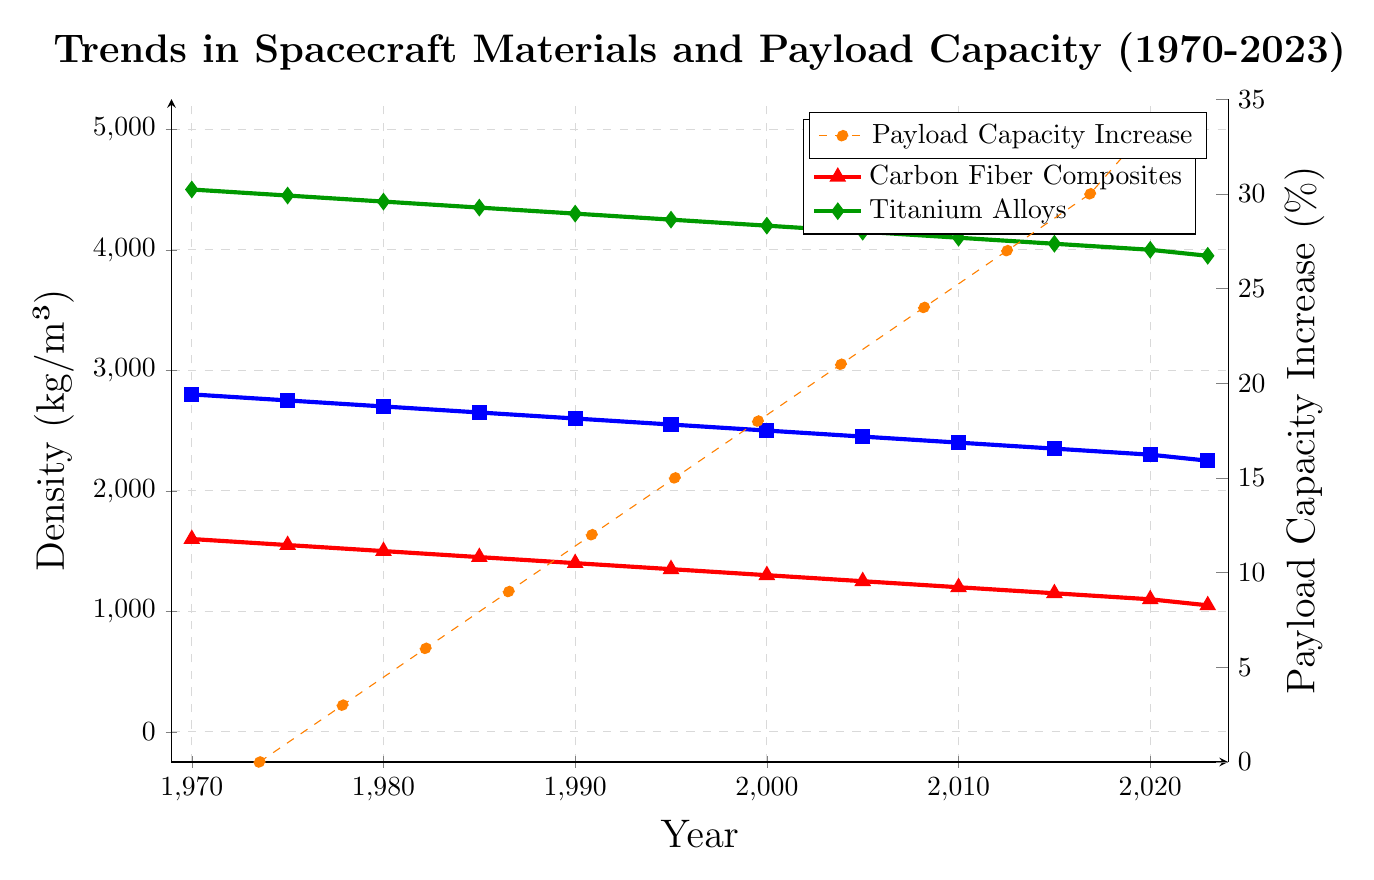Which material saw the greatest reduction in density from 1970 to 2023? To determine the material with the greatest reduction in density, calculate the difference in density for each material between 1970 and 2023. For Aluminum Alloy: 2800 - 2250 = 550 kg/m³. For Carbon Fiber Composites: 1600 - 1050 = 550 kg/m³. For Titanium Alloys: 4500 - 3950 = 550 kg/m³. All materials saw the same reduction in density.
Answer: All materials Between which two consecutive time points did the Payload Capacity Increase by the greatest percentage? To find this, compute the change in Payload Capacity Increase between each pair of consecutive data points: (1970-1975)=(3-0)=3, (1975-1980)=(6-3)=3, (1980-1985)=(9-6)=3, (1985-1990)=(12-9)=3, (1990-1995)=(15-12)=3, (1995-2000)=(18-15)=3, (2000-2005)=(21-18)=3, (2005-2010)=(24-21)=3, (2010-2015)=(27-24)=3, (2015-2020)=(30-27)=3, (2020-2023)=(33-30)=3. Each increment is the same; thus, the greatest increase is the same at each interval.
Answer: All intervals (3%) What is the average density of Titanium Alloys from 1970 to 2023? To find the average density of Titanium Alloys over this period, sum up the densities and divide by the number of years: (4500 + 4450 + 4400 + 4350 + 4300 + 4250 + 4200 + 4150 + 4100 + 4050 + 4000 + 3950) / 12 = 50900 / 12.
Answer: 4241.67 kg/m³ How does the density of Carbon Fiber Composites in 2023 compare to that of Titanium Alloys in the same year? Look at the densities of both materials for the year 2023: Carbon Fiber Composites = 1050 kg/m³, Titanium Alloys = 3950 kg/m³. Since 1050 is less than 3950, the density of Carbon Fiber Composites is much lower.
Answer: Carbon Fiber Composites density is significantly lower What is the trend in the wave graph corresponding to "Payload Capacity Increase" over the years 1970 to 2023? Observe the line pattern for "Payload Capacity Increase," and it shows a steady rising trend from 0% in 1970 to 33% in 2023, without interruptions. This constant increase implies advancements in spacecraft materials directly benefited payload capacities.
Answer: Steadily increasing How much did the density of Aluminum Alloy decrease between 2000 and 2020? Calculate the difference in the density of Aluminum Alloy from 2000 to 2020: 2500 kg/m³ (2000) - 2300 kg/m³ (2020) = 200 kg/m³.
Answer: 200 kg/m³ Which material has the lowest density in 2023, and what is its value? Compare the densities of all materials in 2023: Aluminum Alloy (2250 kg/m³), Carbon Fiber Composites (1050 kg/m³), Titanium Alloys (3950 kg/m³). The lowest density is Carbon Fiber Composites with a value of 1050 kg/m³.
Answer: Carbon Fiber Composites, 1050 kg/m³ 